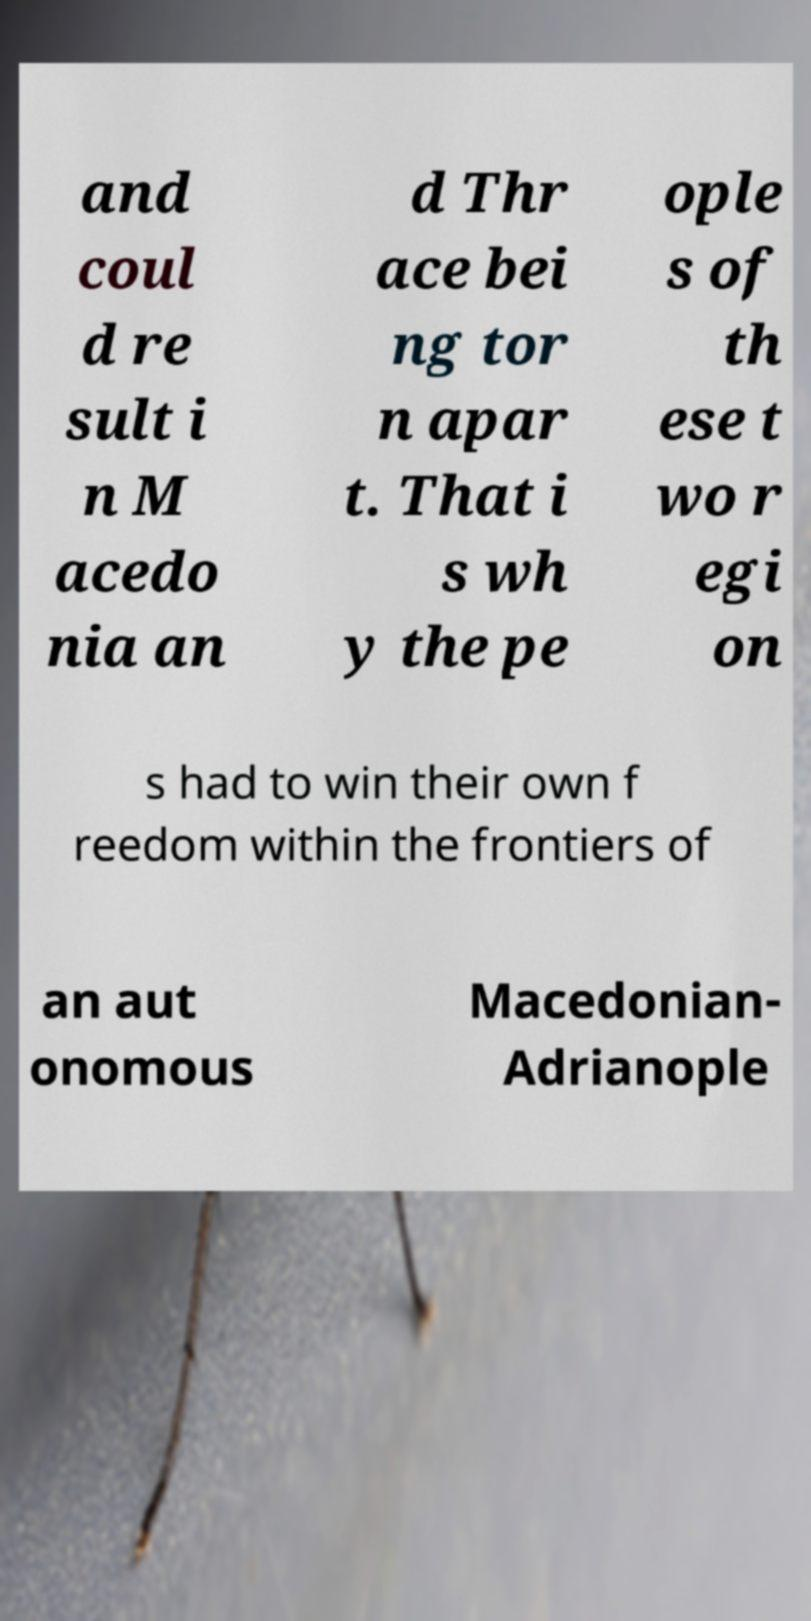I need the written content from this picture converted into text. Can you do that? and coul d re sult i n M acedo nia an d Thr ace bei ng tor n apar t. That i s wh y the pe ople s of th ese t wo r egi on s had to win their own f reedom within the frontiers of an aut onomous Macedonian- Adrianople 